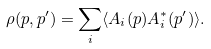Convert formula to latex. <formula><loc_0><loc_0><loc_500><loc_500>\rho ( p , p ^ { \prime } ) = \sum _ { i } \langle A _ { i } ( p ) A _ { i } ^ { * } ( p ^ { \prime } ) \rangle .</formula> 